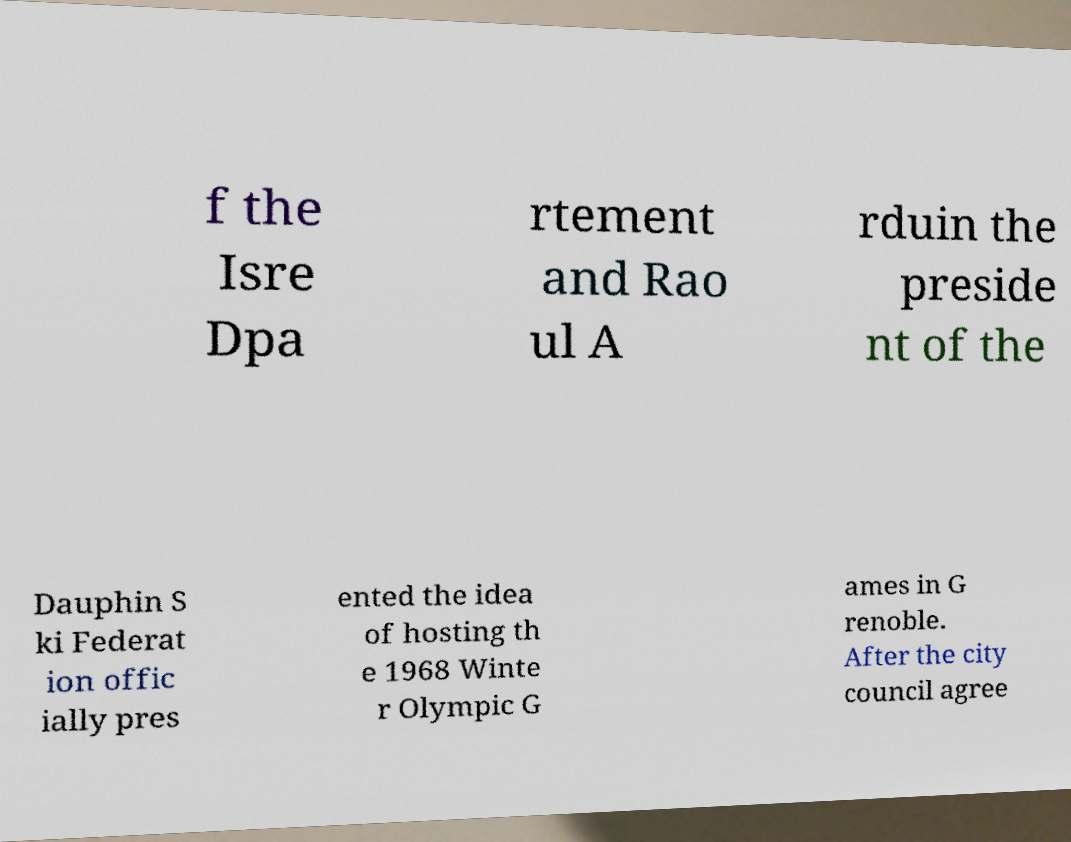Can you read and provide the text displayed in the image?This photo seems to have some interesting text. Can you extract and type it out for me? f the Isre Dpa rtement and Rao ul A rduin the preside nt of the Dauphin S ki Federat ion offic ially pres ented the idea of hosting th e 1968 Winte r Olympic G ames in G renoble. After the city council agree 